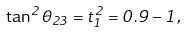Convert formula to latex. <formula><loc_0><loc_0><loc_500><loc_500>\tan ^ { 2 } \theta _ { 2 3 } = t _ { 1 } ^ { 2 } = 0 . 9 - 1 ,</formula> 